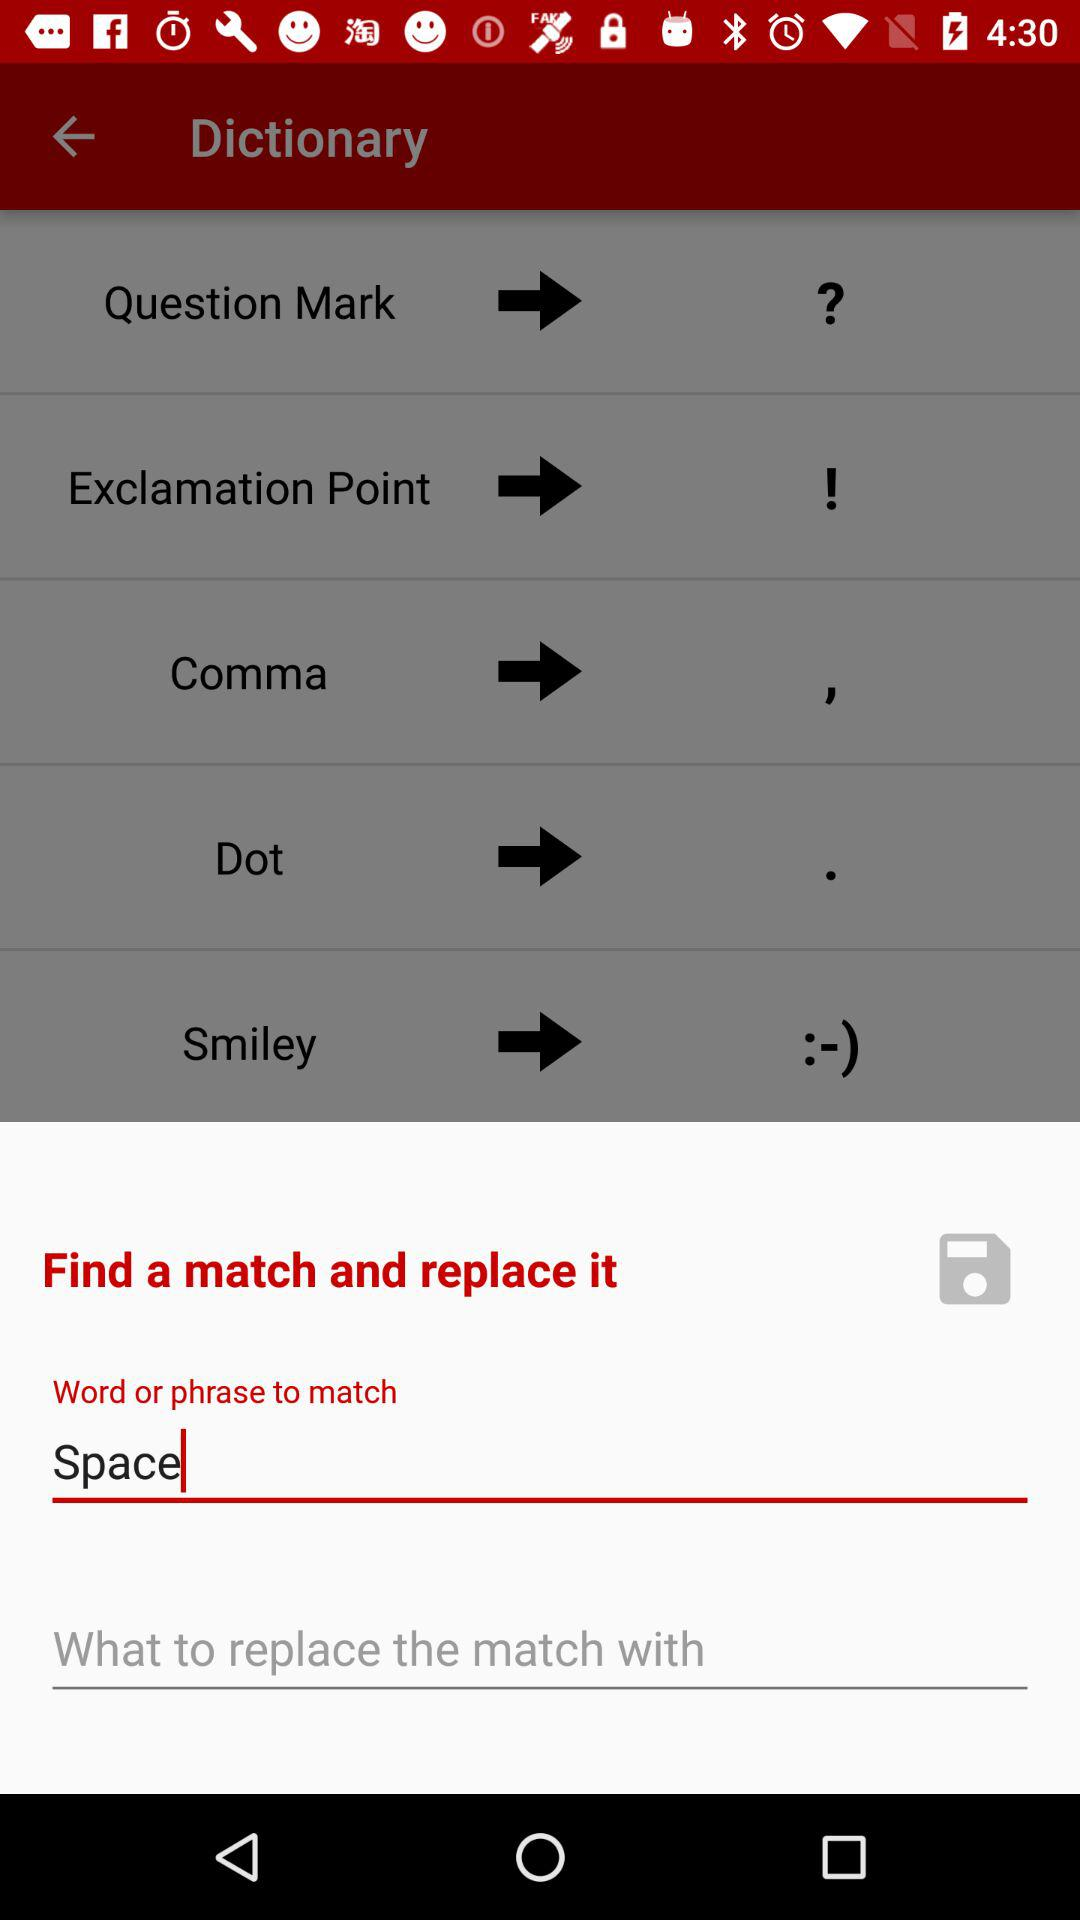How many of the items have a black dot?
Answer the question using a single word or phrase. 1 